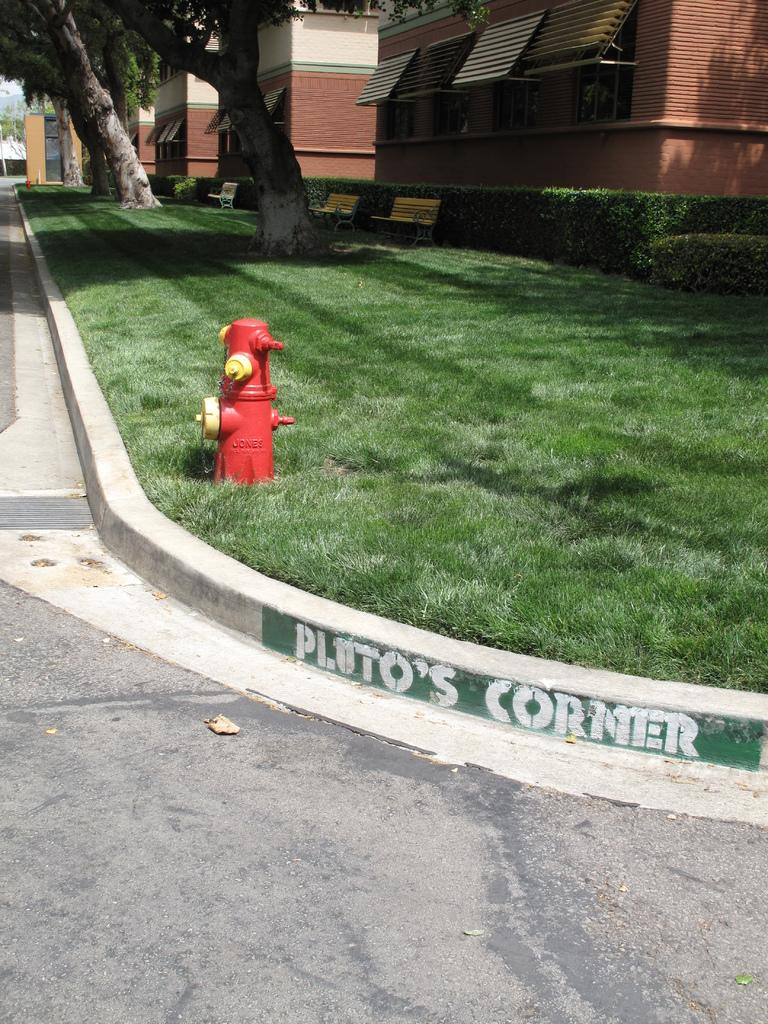What type of structures can be seen in the image? There are buildings in the image. What other natural elements are present in the image? There are trees and grass visible in the image. Can you identify any specific objects in the image? Yes, there is a fire hydrant in the image. What is the color of the fire hydrant? The fire hydrant is red in color. Can you see a pig eating an apple in the image? No, there is no pig or apple present in the image. 